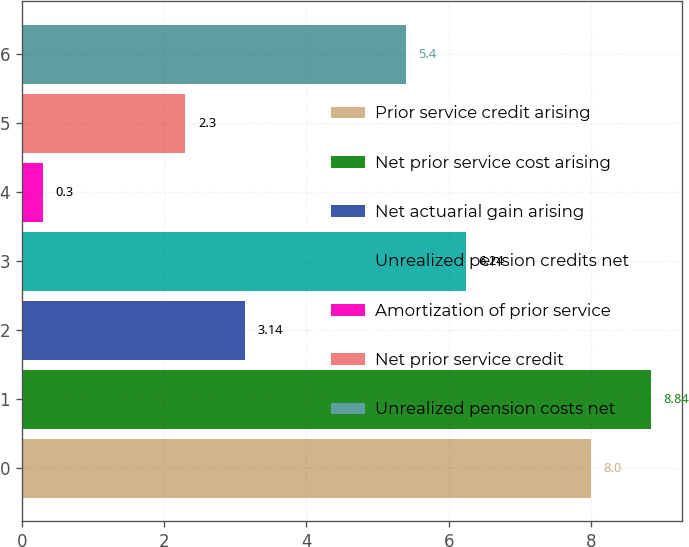Convert chart to OTSL. <chart><loc_0><loc_0><loc_500><loc_500><bar_chart><fcel>Prior service credit arising<fcel>Net prior service cost arising<fcel>Net actuarial gain arising<fcel>Unrealized pension credits net<fcel>Amortization of prior service<fcel>Net prior service credit<fcel>Unrealized pension costs net<nl><fcel>8<fcel>8.84<fcel>3.14<fcel>6.24<fcel>0.3<fcel>2.3<fcel>5.4<nl></chart> 